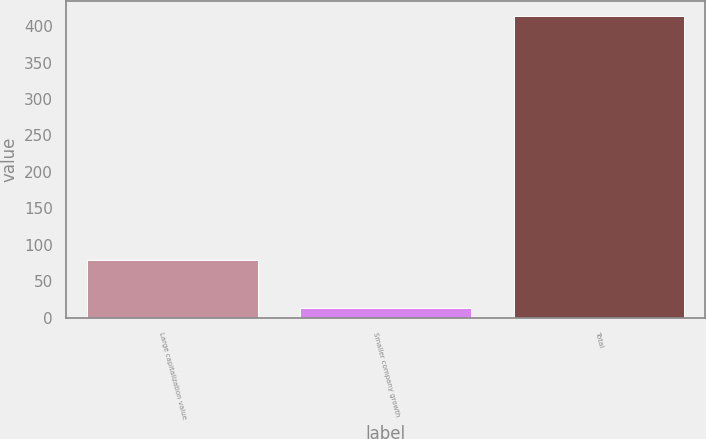Convert chart. <chart><loc_0><loc_0><loc_500><loc_500><bar_chart><fcel>Large capitalization value<fcel>Smaller company growth<fcel>Total<nl><fcel>79<fcel>13<fcel>414<nl></chart> 